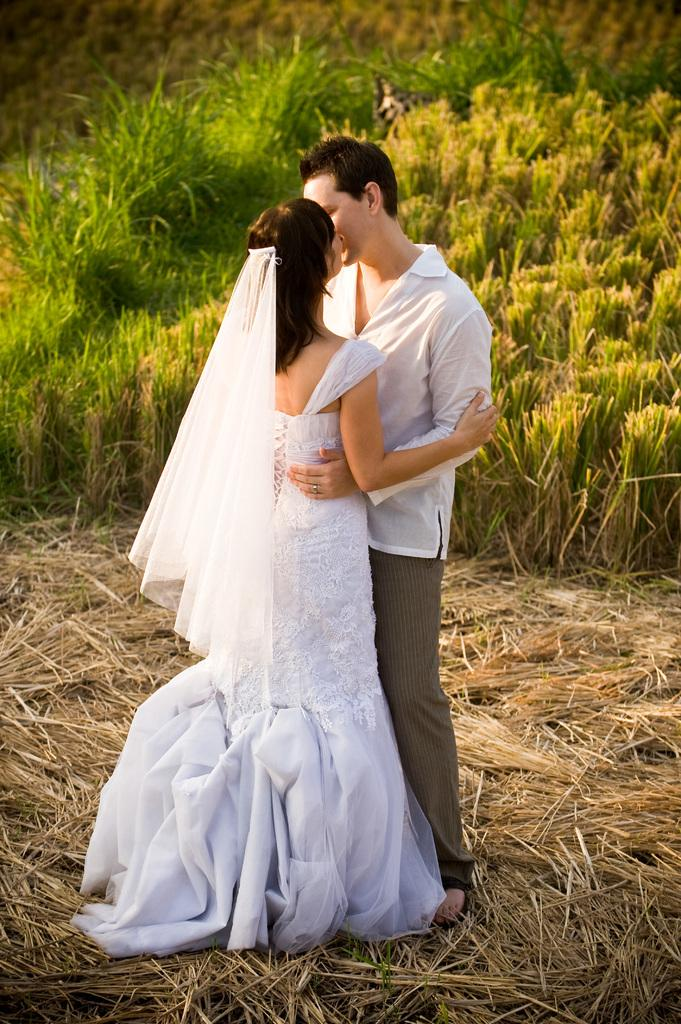How many people are present in the image? There are two people in the image, a man and a woman. What are the positions of the man and woman in the image? Both the man and woman are standing in the image. What can be seen in the background of the image? There are plants visible in the background of the image. What type of hat is the woman wearing in the image? There is no hat visible in the image; the woman is not wearing one. What is the woman using to hang the cord on the hook in the image? There is no cord or hook present in the image. 